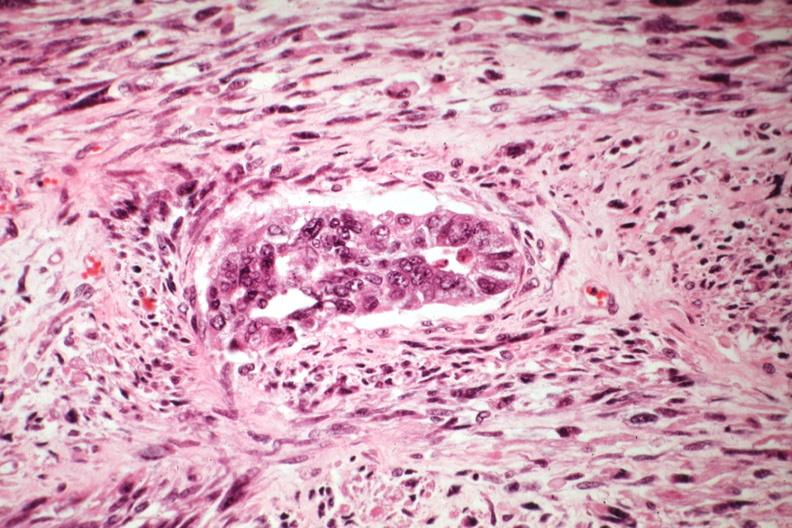s metastatic carcinoma oat cell present?
Answer the question using a single word or phrase. No 